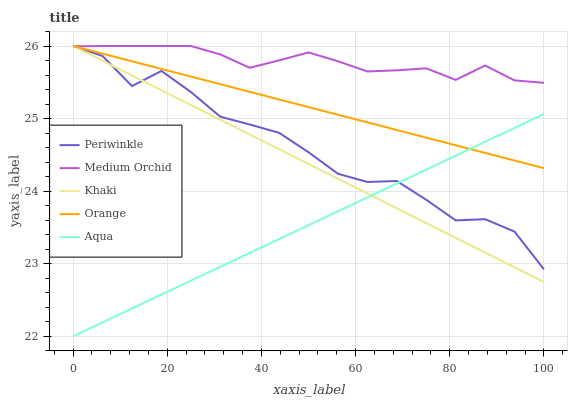Does Aqua have the minimum area under the curve?
Answer yes or no. Yes. Does Medium Orchid have the maximum area under the curve?
Answer yes or no. Yes. Does Medium Orchid have the minimum area under the curve?
Answer yes or no. No. Does Aqua have the maximum area under the curve?
Answer yes or no. No. Is Aqua the smoothest?
Answer yes or no. Yes. Is Periwinkle the roughest?
Answer yes or no. Yes. Is Medium Orchid the smoothest?
Answer yes or no. No. Is Medium Orchid the roughest?
Answer yes or no. No. Does Aqua have the lowest value?
Answer yes or no. Yes. Does Medium Orchid have the lowest value?
Answer yes or no. No. Does Khaki have the highest value?
Answer yes or no. Yes. Does Aqua have the highest value?
Answer yes or no. No. Is Aqua less than Medium Orchid?
Answer yes or no. Yes. Is Medium Orchid greater than Aqua?
Answer yes or no. Yes. Does Orange intersect Khaki?
Answer yes or no. Yes. Is Orange less than Khaki?
Answer yes or no. No. Is Orange greater than Khaki?
Answer yes or no. No. Does Aqua intersect Medium Orchid?
Answer yes or no. No. 